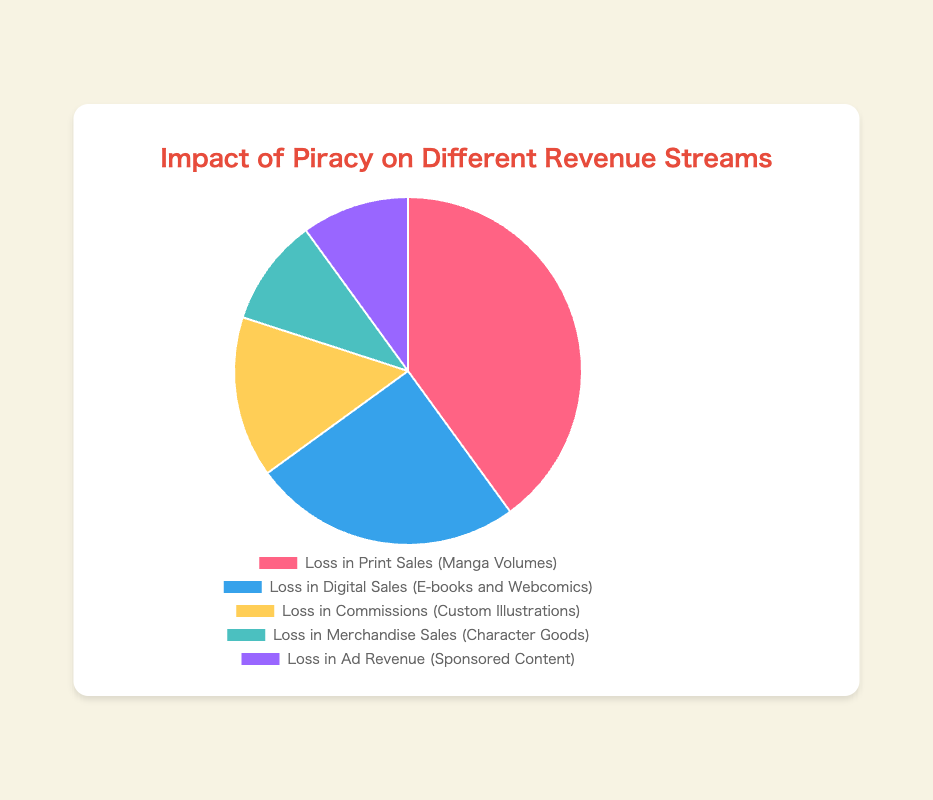Which revenue stream has the highest impact from piracy? The chart shows the largest percentage for Loss in Print Sales, which is 40%.
Answer: Loss in Print Sales How much greater is the loss in print sales compared to digital sales? The loss in print sales is 40%, and the loss in digital sales is 25%. Subtracting these gives 40% - 25% = 15%.
Answer: 15% What is the total percentage impact of piracy on commissions and merchandise sales combined? The loss in commissions is 15%, and the loss in merchandise sales is 10%. Adding these together gives 15% + 10% = 25%.
Answer: 25% Which category has the smallest impact from piracy? The smallest percentages shown are for Loss in Merchandise Sales and Loss in Ad Revenue, both at 10%.
Answer: Loss in Merchandise Sales and Loss in Ad Revenue Is the impact on commissions more or less than that on ad revenue? The chart shows that the loss in commissions is 15%, whereas the loss in ad revenue is 10%. Comparing these, 15% is greater than 10%.
Answer: More What is the difference between the impact on digital sales and ad revenue? The loss in digital sales is 25%, and the loss in ad revenue is 10%. Subtracting these gives 25% - 10% = 15%.
Answer: 15% Which revenue stream represented by the light blue segment of the chart? The light blue segment represents Loss in Merchandise Sales.
Answer: Loss in Merchandise Sales How does the impact on custom illustrations compare to that on character goods? The loss in commissions (custom illustrations) is 15%, while the loss in merchandise sales (character goods) is 10%. Therefore, the impact is greater on commissions than on merchandise sales.
Answer: Greater on commissions What is the average percentage impact across all five revenue streams? The percentages are 40%, 25%, 15%, 10%, and 10%. Adding these gives a total of 40 + 25 + 15 + 10 + 10 = 100. Dividing by the number of streams (5) gives 100 / 5 = 20%.
Answer: 20% What is the combined impact percentage on print and digital sales? The loss in print sales is 40%, and the loss in digital sales is 25%. Adding these together gives 40% + 25% = 65%.
Answer: 65% 